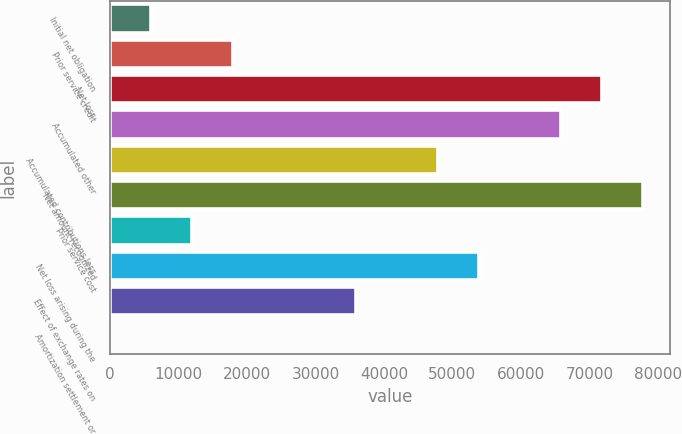<chart> <loc_0><loc_0><loc_500><loc_500><bar_chart><fcel>Initial net obligation<fcel>Prior service credit<fcel>Net loss<fcel>Accumulated other<fcel>Accumulated contributions less<fcel>Net amount recognized<fcel>Prior service cost<fcel>Net loss arising during the<fcel>Effect of exchange rates on<fcel>Amortization settlement or<nl><fcel>6004.1<fcel>17978.3<fcel>71862.2<fcel>65875.1<fcel>47913.8<fcel>77849.3<fcel>11991.2<fcel>53900.9<fcel>35939.6<fcel>17<nl></chart> 